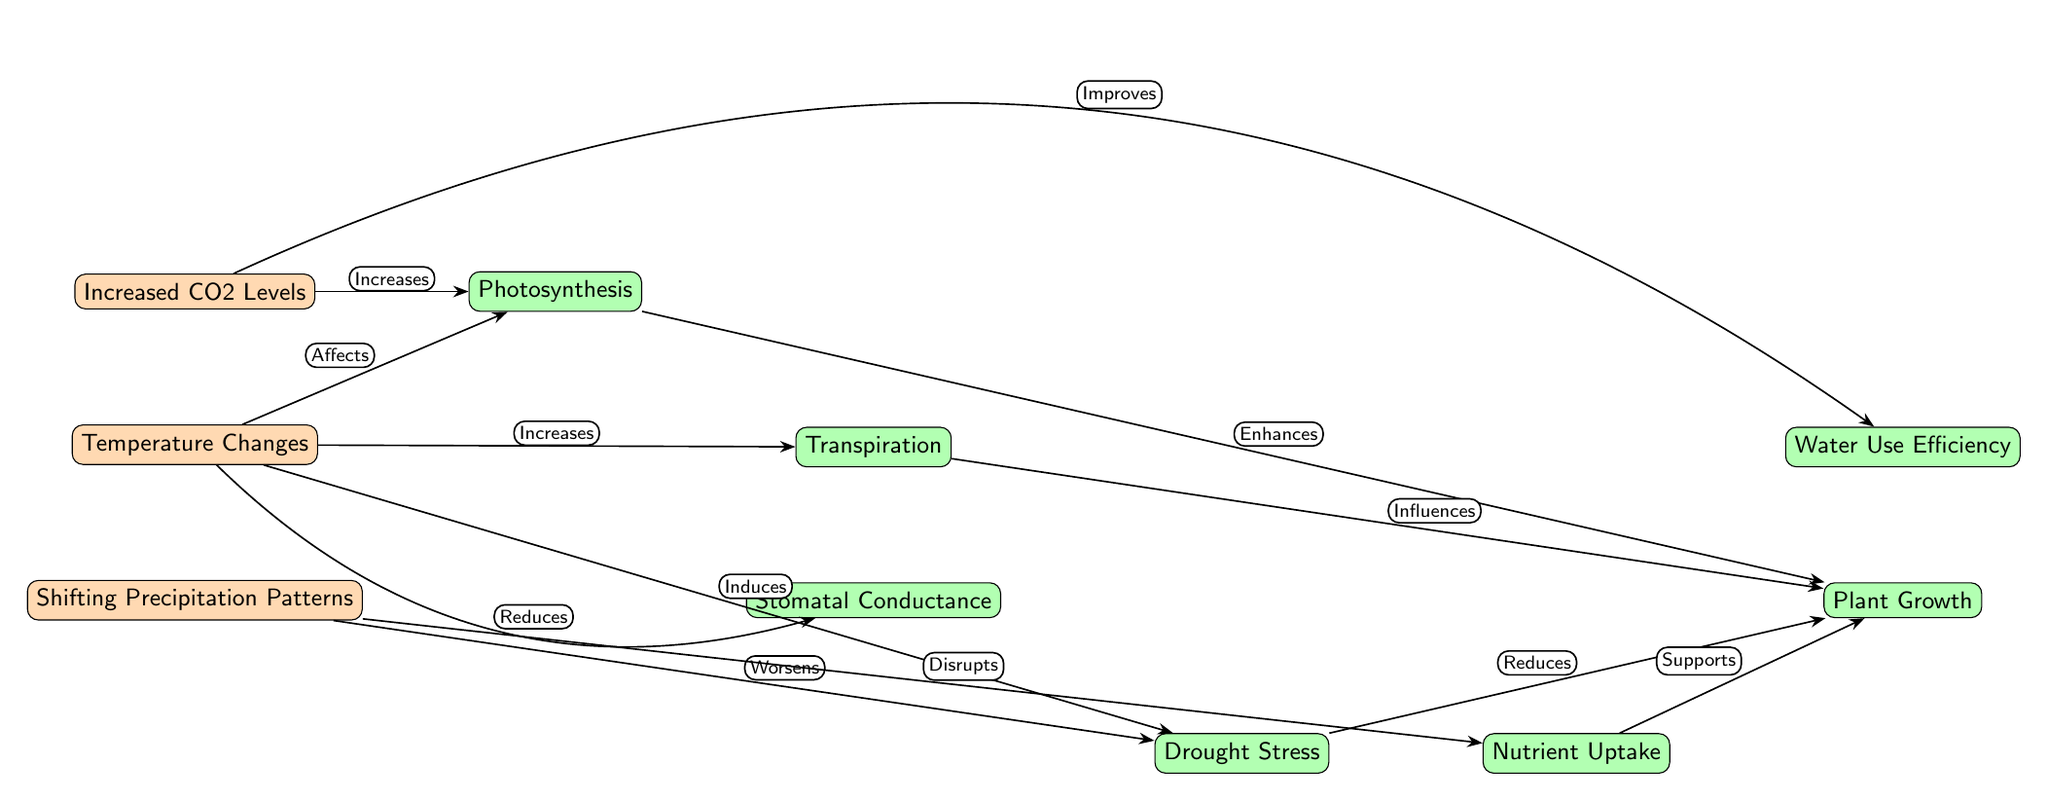What are the three climate change factors depicted in the diagram? The diagram shows three climate change factors represented as nodes: Increased CO2 Levels, Temperature Changes, and Shifting Precipitation Patterns.
Answer: Increased CO2 Levels, Temperature Changes, Shifting Precipitation Patterns How does increased CO2 levels affect photosynthesis? The arrow connecting "Increased CO2 Levels" and "Photosynthesis" is labeled "Increases," indicating that increased CO2 levels enhance the process of photosynthesis.
Answer: Increases What is the impact of temperature changes on stomatal conductance? The diagram shows an arrow from "Temperature Changes" to "Stomatal Conductance" labeled "Reduces," indicating that temperature changes lead to a reduction in stomatal conductance.
Answer: Reduces How many processes related to plant physiology are shown in the diagram? The diagram displays seven nodes categorized as plant physiological processes: Photosynthesis, Transpiration, Stomatal Conductance, Drought Stress, Nutrient Uptake, Plant Growth, and Water Use Efficiency. Counting these nodes gives a total of seven.
Answer: 7 Which climate change factor worsens drought stress according to the diagram? The arrow from "Shifting Precipitation Patterns" to "Drought Stress" is labeled "Worsens," indicating that changes in precipitation patterns negatively impact drought stress.
Answer: Shifting Precipitation Patterns How does transpiration influence plant growth? There is an arrow connecting "Transpiration" and "Plant Growth," labeled "Influences," suggesting that transpiration has a positive effect on the growth of plants.
Answer: Influences What two factors are connected to nutrient uptake in the diagram? The diagram connects "Nutrient Uptake" to two nodes: "Temperature Changes" (as disrupted) and "Photosynthesis" (as supportive). This shows that both factors have an influence on nutrient uptake through different pathways.
Answer: Temperature Changes, Photosynthesis What is the relationship between drought stress and plant growth? An arrow connects "Drought Stress" to "Plant Growth," and it is labeled "Reduces," indicating that increased drought stress negatively affects plant growth.
Answer: Reduces 